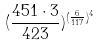<formula> <loc_0><loc_0><loc_500><loc_500>( \frac { 4 5 1 \cdot 3 } { 4 2 3 } ) ^ { ( \frac { 6 } { 1 1 7 } ) ^ { 4 } }</formula> 